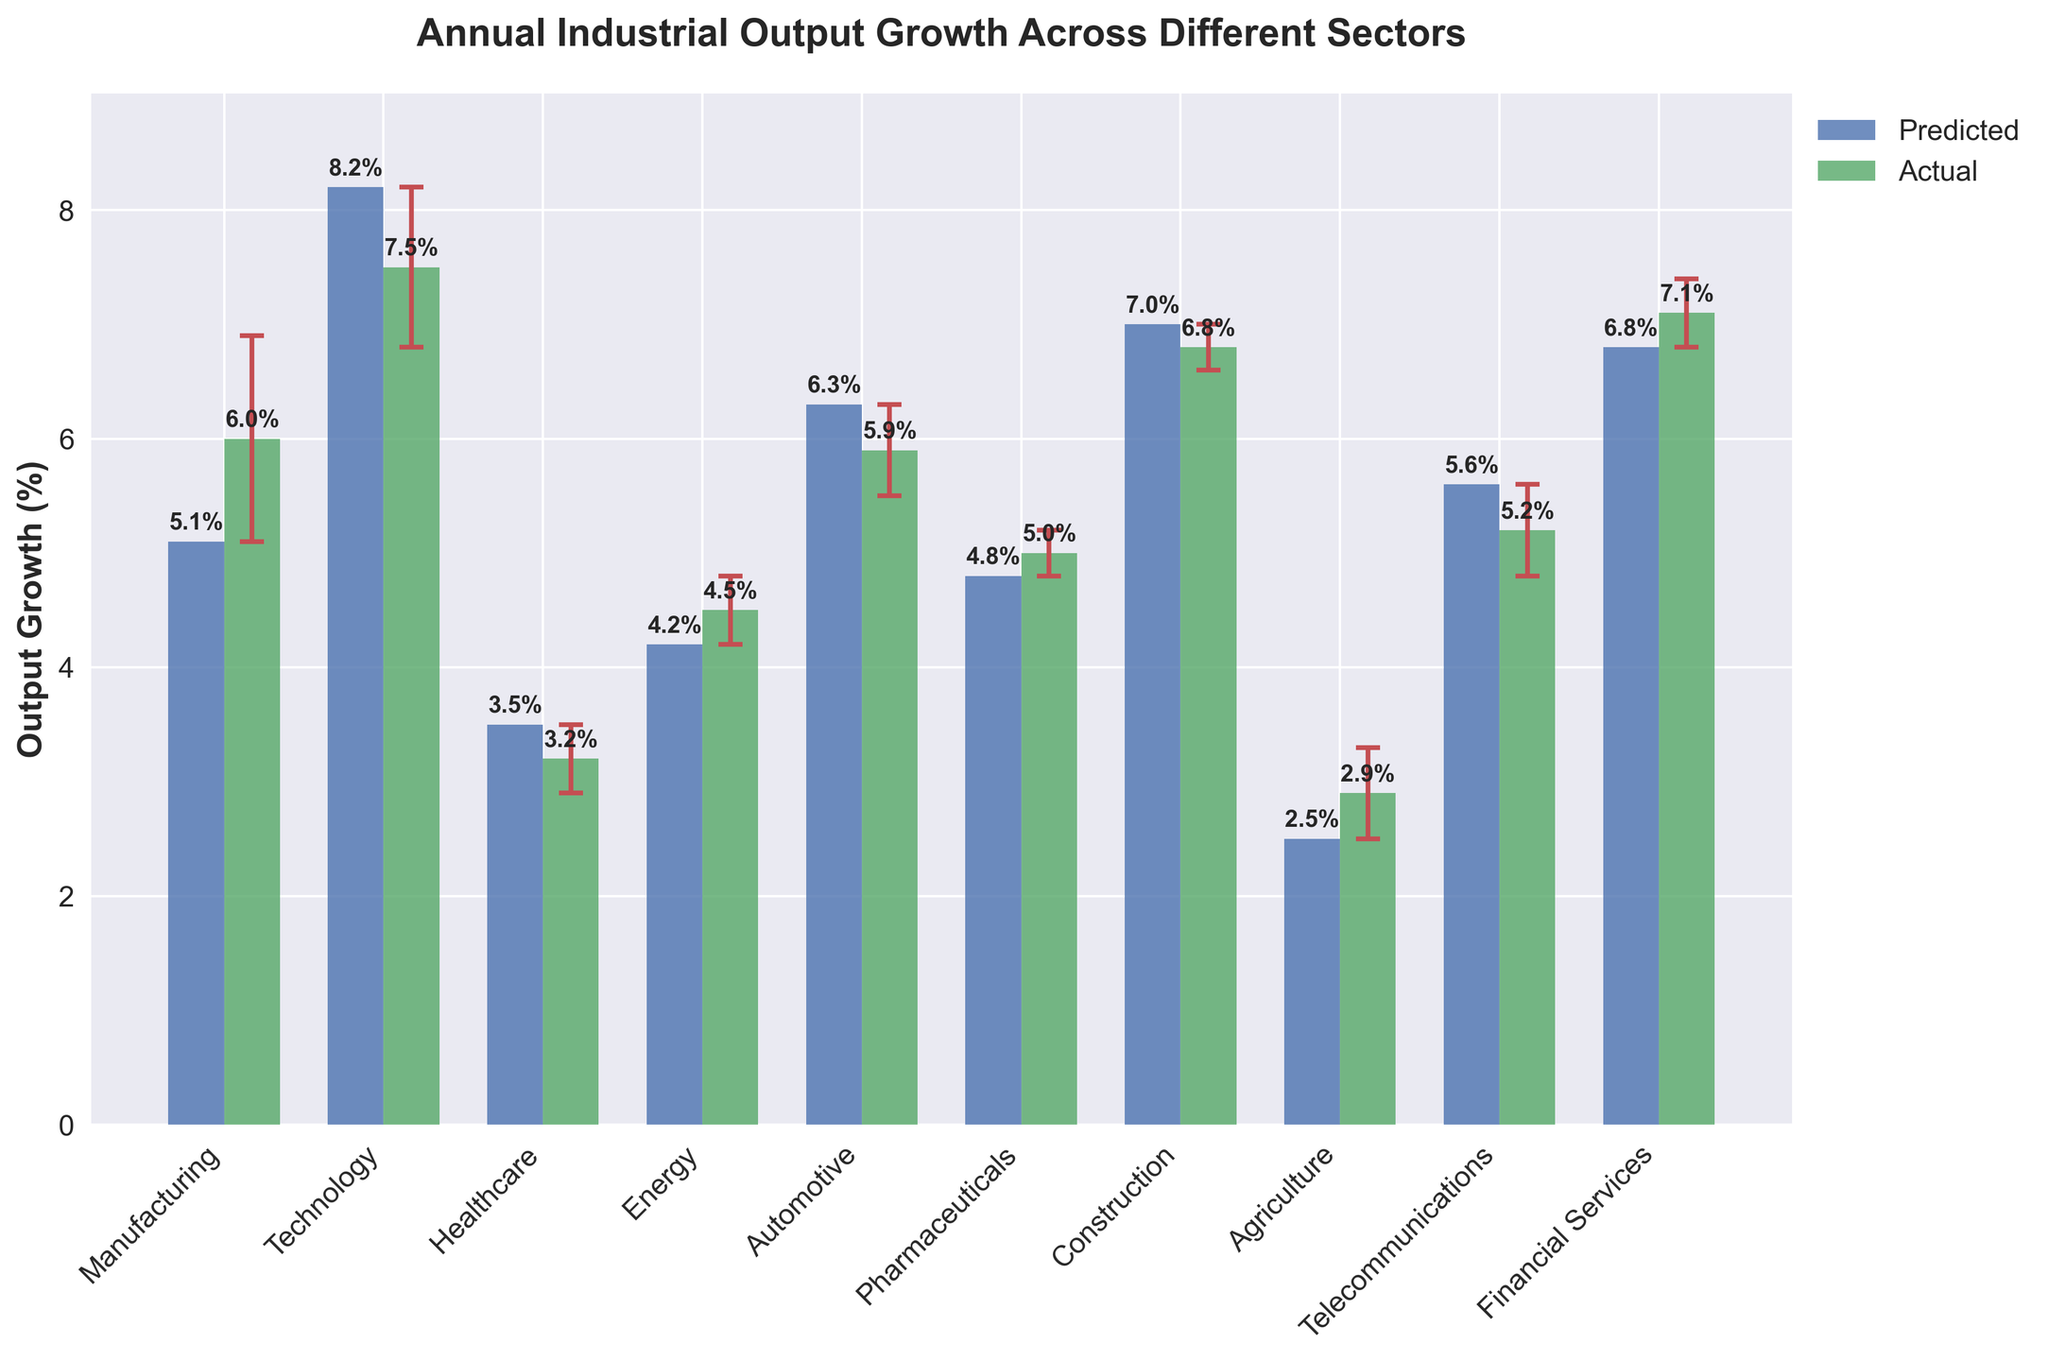How many sectors are represented in the figure? There are 10 different sector names listed on the x-axis in the figure.
Answer: 10 What color represents the actual output growth in the figure? The bars representing the actual output growth are in green color.
Answer: Green Which sector shows the highest actual output growth? From the plotted bars, the Technology sector has the highest actual output growth at 7.5%.
Answer: Technology What is the predicted output growth for the Manufacturing sector? The bar representing the predicted output growth for the Manufacturing sector shows a value of 5.1%.
Answer: 5.1% Which sectors have actual output growth greater than predicted output growth? Comparing the heights of the actual and predicted bars, Manufacturing, Energy, Pharmaceuticals, Agriculture, and Financial Services sectors have actual output growth greater than predicted output growth.
Answer: Manufacturing, Energy, Pharmaceuticals, Agriculture, Financial Services What is the difference between the predicted and actual output growth for the Automotive sector? The predicted output growth for Automotive is 6.3%, and the actual output growth is 5.9%. Thus, the difference is 6.3% - 5.9% = 0.4%.
Answer: 0.4% Which sector has the smallest error bar in the actual output growth? The Pharmaceuticals and Construction sectors have the smallest error bars of 0.2%, as depicted by the error bars on top of the bars in the figure.
Answer: Pharmaceuticals, Construction What is the average actual output growth across all sectors? Sum the actual output growth for all sectors (6.0 + 7.5 + 3.2 + 4.5 + 5.9 + 5.0 + 6.8 + 2.9 + 5.2 + 7.1) = 54.1, and divide by the number of sectors (10), leading to an average of 54.1 / 10 = 5.41%.
Answer: 5.41% Is the actual output growth in the Healthcare sector within the error margin of the predicted output growth? The predicted growth for Healthcare is 3.5% with an actual growth of 3.2% and no error for the predicted value given. The actual growth falls within the error bar range of predicted got is small in both values given.
Answer: Yes Which sector shows the lowest difference between predicted and actual values? By comparing differences for each sector, the Pharmaceuticals sector has the smallest difference of 0.2% (predicted 4.8% - actual 5.0%).
Answer: Pharmaceuticals 